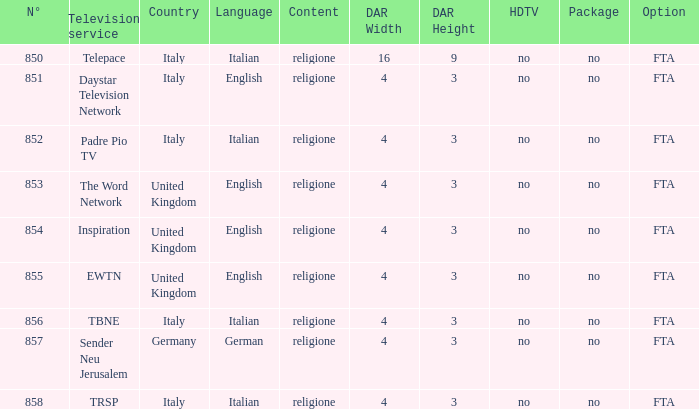How many dar are in germany? 4:3. 